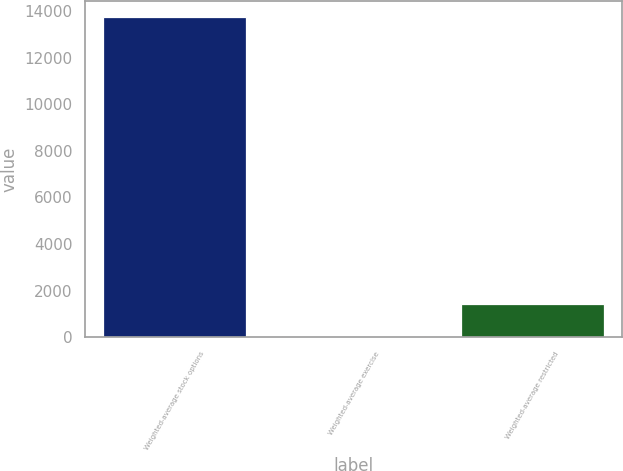Convert chart to OTSL. <chart><loc_0><loc_0><loc_500><loc_500><bar_chart><fcel>Weighted-average stock options<fcel>Weighted-average exercise<fcel>Weighted-average restricted<nl><fcel>13737<fcel>57.54<fcel>1425.49<nl></chart> 